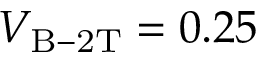<formula> <loc_0><loc_0><loc_500><loc_500>V _ { B - 2 T } = 0 . 2 5</formula> 